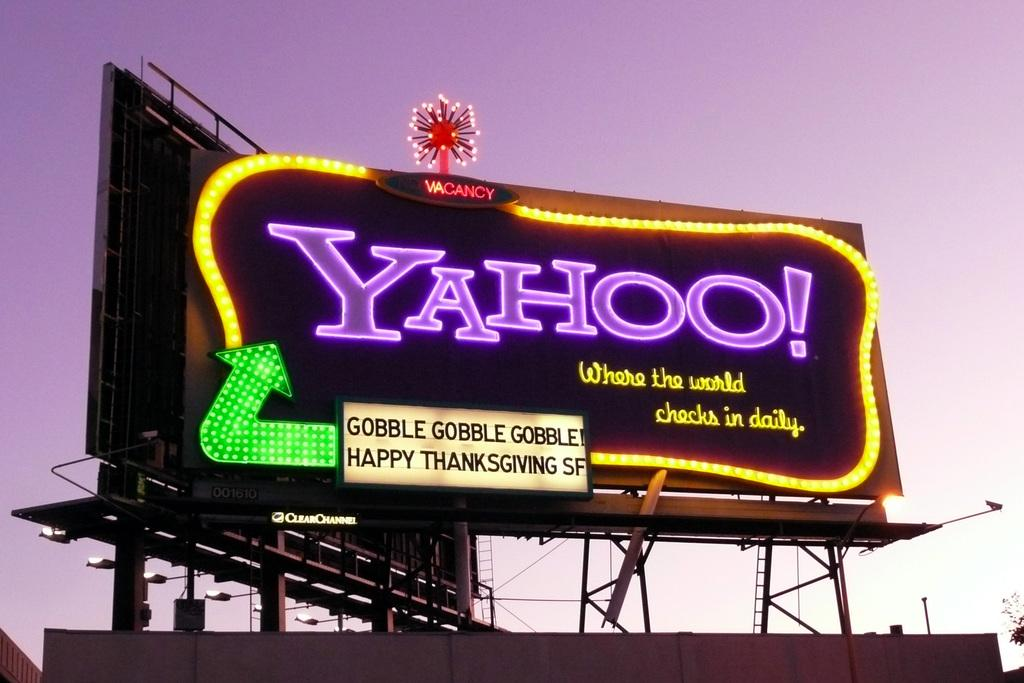Provide a one-sentence caption for the provided image. A  neon billboard with purple letters saying Yahoo. 